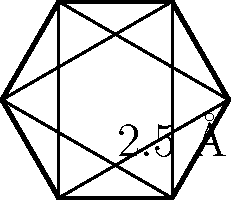Consider the planar structure of benzene, a common aromatic compound. The hexagonal shape represents the carbon skeleton, where each vertex is a carbon atom. Given that the C-C bond length in benzene is 2.5 Å (angstroms), calculate the area of the benzene molecule in square angstroms (Å²). Round your answer to two decimal places. To calculate the area of the benzene molecule, we'll follow these steps:

1) First, recognize that benzene forms a regular hexagon.

2) The area of a regular hexagon is given by the formula:

   $$A = \frac{3\sqrt{3}}{2}s^2$$

   where $s$ is the side length.

3) We're given the C-C bond length (2.5 Å), but this is not the side length of the hexagon. The side of the hexagon is formed by two bond lengths at 120° to each other.

4) To find the side length, we can use the law of cosines:

   $$s^2 = (2.5)^2 + (2.5)^2 - 2(2.5)(2.5)\cos(120°)$$

5) Simplify:
   $$s^2 = 12.5 - 12.5(-0.5) = 18.75$$
   $$s = \sqrt{18.75} = 4.33$$

6) Now we can plug this into our hexagon area formula:

   $$A = \frac{3\sqrt{3}}{2}(4.33)^2$$

7) Calculate:
   $$A = 48.67 \text{ Å}^2$$

8) Rounding to two decimal places:
   $$A = 48.67 \text{ Å}^2$$
Answer: 48.67 Å² 